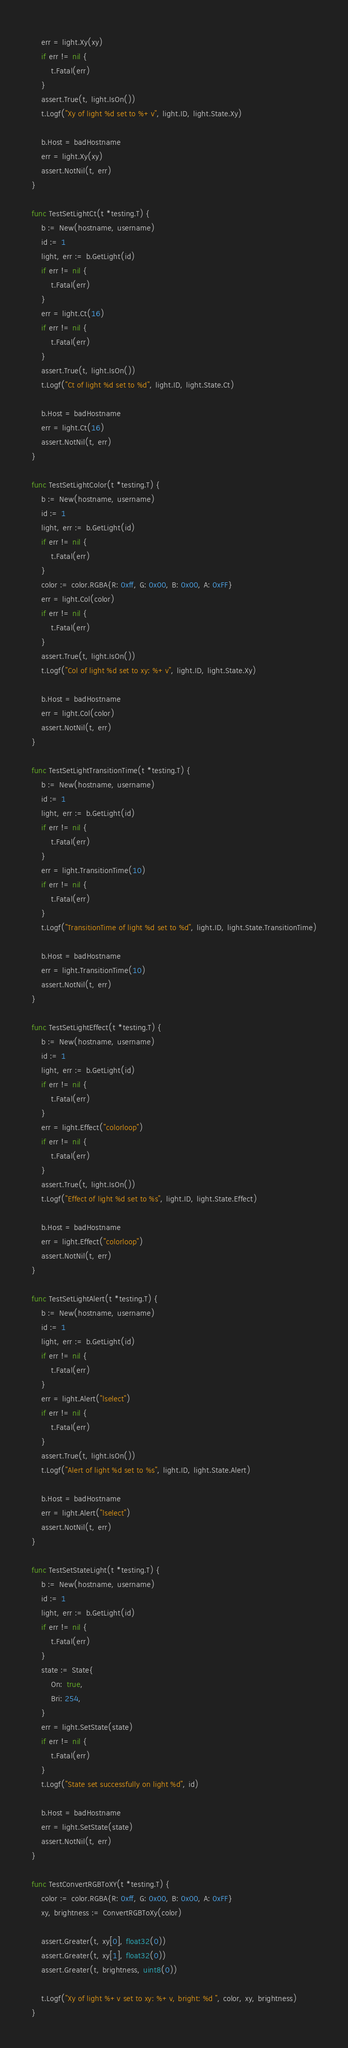<code> <loc_0><loc_0><loc_500><loc_500><_Go_>	err = light.Xy(xy)
	if err != nil {
		t.Fatal(err)
	}
	assert.True(t, light.IsOn())
	t.Logf("Xy of light %d set to %+v", light.ID, light.State.Xy)

	b.Host = badHostname
	err = light.Xy(xy)
	assert.NotNil(t, err)
}

func TestSetLightCt(t *testing.T) {
	b := New(hostname, username)
	id := 1
	light, err := b.GetLight(id)
	if err != nil {
		t.Fatal(err)
	}
	err = light.Ct(16)
	if err != nil {
		t.Fatal(err)
	}
	assert.True(t, light.IsOn())
	t.Logf("Ct of light %d set to %d", light.ID, light.State.Ct)

	b.Host = badHostname
	err = light.Ct(16)
	assert.NotNil(t, err)
}

func TestSetLightColor(t *testing.T) {
	b := New(hostname, username)
	id := 1
	light, err := b.GetLight(id)
	if err != nil {
		t.Fatal(err)
	}
	color := color.RGBA{R: 0xff, G: 0x00, B: 0x00, A: 0xFF}
	err = light.Col(color)
	if err != nil {
		t.Fatal(err)
	}
	assert.True(t, light.IsOn())
	t.Logf("Col of light %d set to xy: %+v", light.ID, light.State.Xy)

	b.Host = badHostname
	err = light.Col(color)
	assert.NotNil(t, err)
}

func TestSetLightTransitionTime(t *testing.T) {
	b := New(hostname, username)
	id := 1
	light, err := b.GetLight(id)
	if err != nil {
		t.Fatal(err)
	}
	err = light.TransitionTime(10)
	if err != nil {
		t.Fatal(err)
	}
	t.Logf("TransitionTime of light %d set to %d", light.ID, light.State.TransitionTime)

	b.Host = badHostname
	err = light.TransitionTime(10)
	assert.NotNil(t, err)
}

func TestSetLightEffect(t *testing.T) {
	b := New(hostname, username)
	id := 1
	light, err := b.GetLight(id)
	if err != nil {
		t.Fatal(err)
	}
	err = light.Effect("colorloop")
	if err != nil {
		t.Fatal(err)
	}
	assert.True(t, light.IsOn())
	t.Logf("Effect of light %d set to %s", light.ID, light.State.Effect)

	b.Host = badHostname
	err = light.Effect("colorloop")
	assert.NotNil(t, err)
}

func TestSetLightAlert(t *testing.T) {
	b := New(hostname, username)
	id := 1
	light, err := b.GetLight(id)
	if err != nil {
		t.Fatal(err)
	}
	err = light.Alert("lselect")
	if err != nil {
		t.Fatal(err)
	}
	assert.True(t, light.IsOn())
	t.Logf("Alert of light %d set to %s", light.ID, light.State.Alert)

	b.Host = badHostname
	err = light.Alert("lselect")
	assert.NotNil(t, err)
}

func TestSetStateLight(t *testing.T) {
	b := New(hostname, username)
	id := 1
	light, err := b.GetLight(id)
	if err != nil {
		t.Fatal(err)
	}
	state := State{
		On:  true,
		Bri: 254,
	}
	err = light.SetState(state)
	if err != nil {
		t.Fatal(err)
	}
	t.Logf("State set successfully on light %d", id)

	b.Host = badHostname
	err = light.SetState(state)
	assert.NotNil(t, err)
}

func TestConvertRGBToXY(t *testing.T) {
	color := color.RGBA{R: 0xff, G: 0x00, B: 0x00, A: 0xFF}
	xy, brightness := ConvertRGBToXy(color)

	assert.Greater(t, xy[0], float32(0))
	assert.Greater(t, xy[1], float32(0))
	assert.Greater(t, brightness, uint8(0))

	t.Logf("Xy of light %+v set to xy: %+v, bright: %d ", color, xy, brightness)
}
</code> 